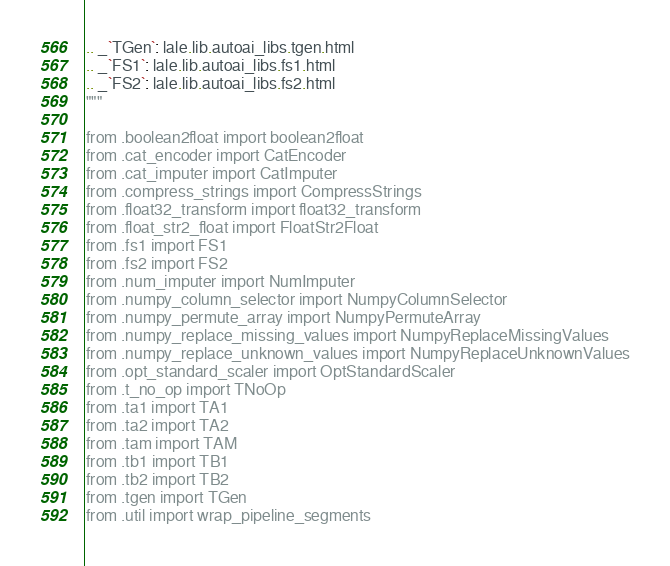Convert code to text. <code><loc_0><loc_0><loc_500><loc_500><_Python_>.. _`TGen`: lale.lib.autoai_libs.tgen.html
.. _`FS1`: lale.lib.autoai_libs.fs1.html
.. _`FS2`: lale.lib.autoai_libs.fs2.html
"""

from .boolean2float import boolean2float
from .cat_encoder import CatEncoder
from .cat_imputer import CatImputer
from .compress_strings import CompressStrings
from .float32_transform import float32_transform
from .float_str2_float import FloatStr2Float
from .fs1 import FS1
from .fs2 import FS2
from .num_imputer import NumImputer
from .numpy_column_selector import NumpyColumnSelector
from .numpy_permute_array import NumpyPermuteArray
from .numpy_replace_missing_values import NumpyReplaceMissingValues
from .numpy_replace_unknown_values import NumpyReplaceUnknownValues
from .opt_standard_scaler import OptStandardScaler
from .t_no_op import TNoOp
from .ta1 import TA1
from .ta2 import TA2
from .tam import TAM
from .tb1 import TB1
from .tb2 import TB2
from .tgen import TGen
from .util import wrap_pipeline_segments
</code> 